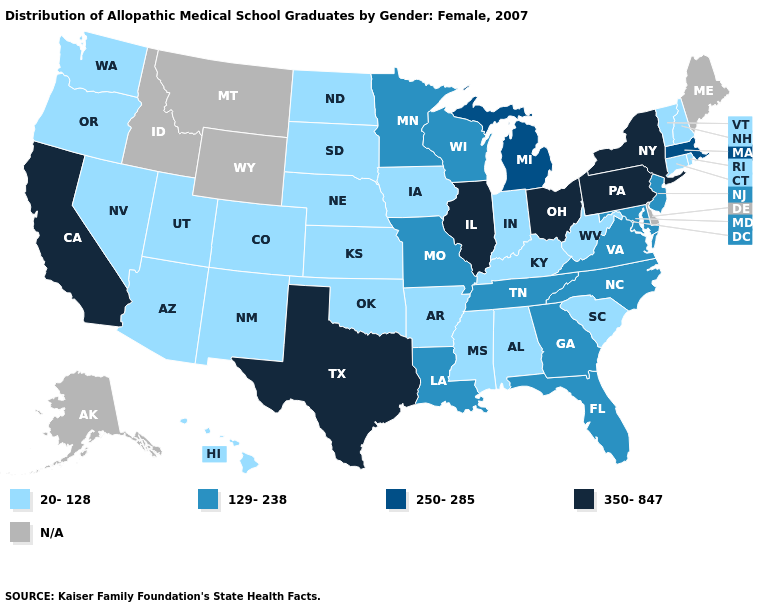Does the first symbol in the legend represent the smallest category?
Concise answer only. Yes. What is the highest value in states that border Tennessee?
Write a very short answer. 129-238. Name the states that have a value in the range 20-128?
Keep it brief. Alabama, Arizona, Arkansas, Colorado, Connecticut, Hawaii, Indiana, Iowa, Kansas, Kentucky, Mississippi, Nebraska, Nevada, New Hampshire, New Mexico, North Dakota, Oklahoma, Oregon, Rhode Island, South Carolina, South Dakota, Utah, Vermont, Washington, West Virginia. What is the value of Maine?
Be succinct. N/A. Among the states that border Ohio , which have the lowest value?
Concise answer only. Indiana, Kentucky, West Virginia. Name the states that have a value in the range 350-847?
Quick response, please. California, Illinois, New York, Ohio, Pennsylvania, Texas. Which states have the highest value in the USA?
Give a very brief answer. California, Illinois, New York, Ohio, Pennsylvania, Texas. What is the value of Montana?
Quick response, please. N/A. Name the states that have a value in the range N/A?
Write a very short answer. Alaska, Delaware, Idaho, Maine, Montana, Wyoming. Name the states that have a value in the range 250-285?
Answer briefly. Massachusetts, Michigan. Which states have the highest value in the USA?
Answer briefly. California, Illinois, New York, Ohio, Pennsylvania, Texas. Does California have the lowest value in the West?
Write a very short answer. No. What is the value of Nevada?
Short answer required. 20-128. Does Ohio have the highest value in the MidWest?
Write a very short answer. Yes. Does Vermont have the lowest value in the USA?
Give a very brief answer. Yes. 